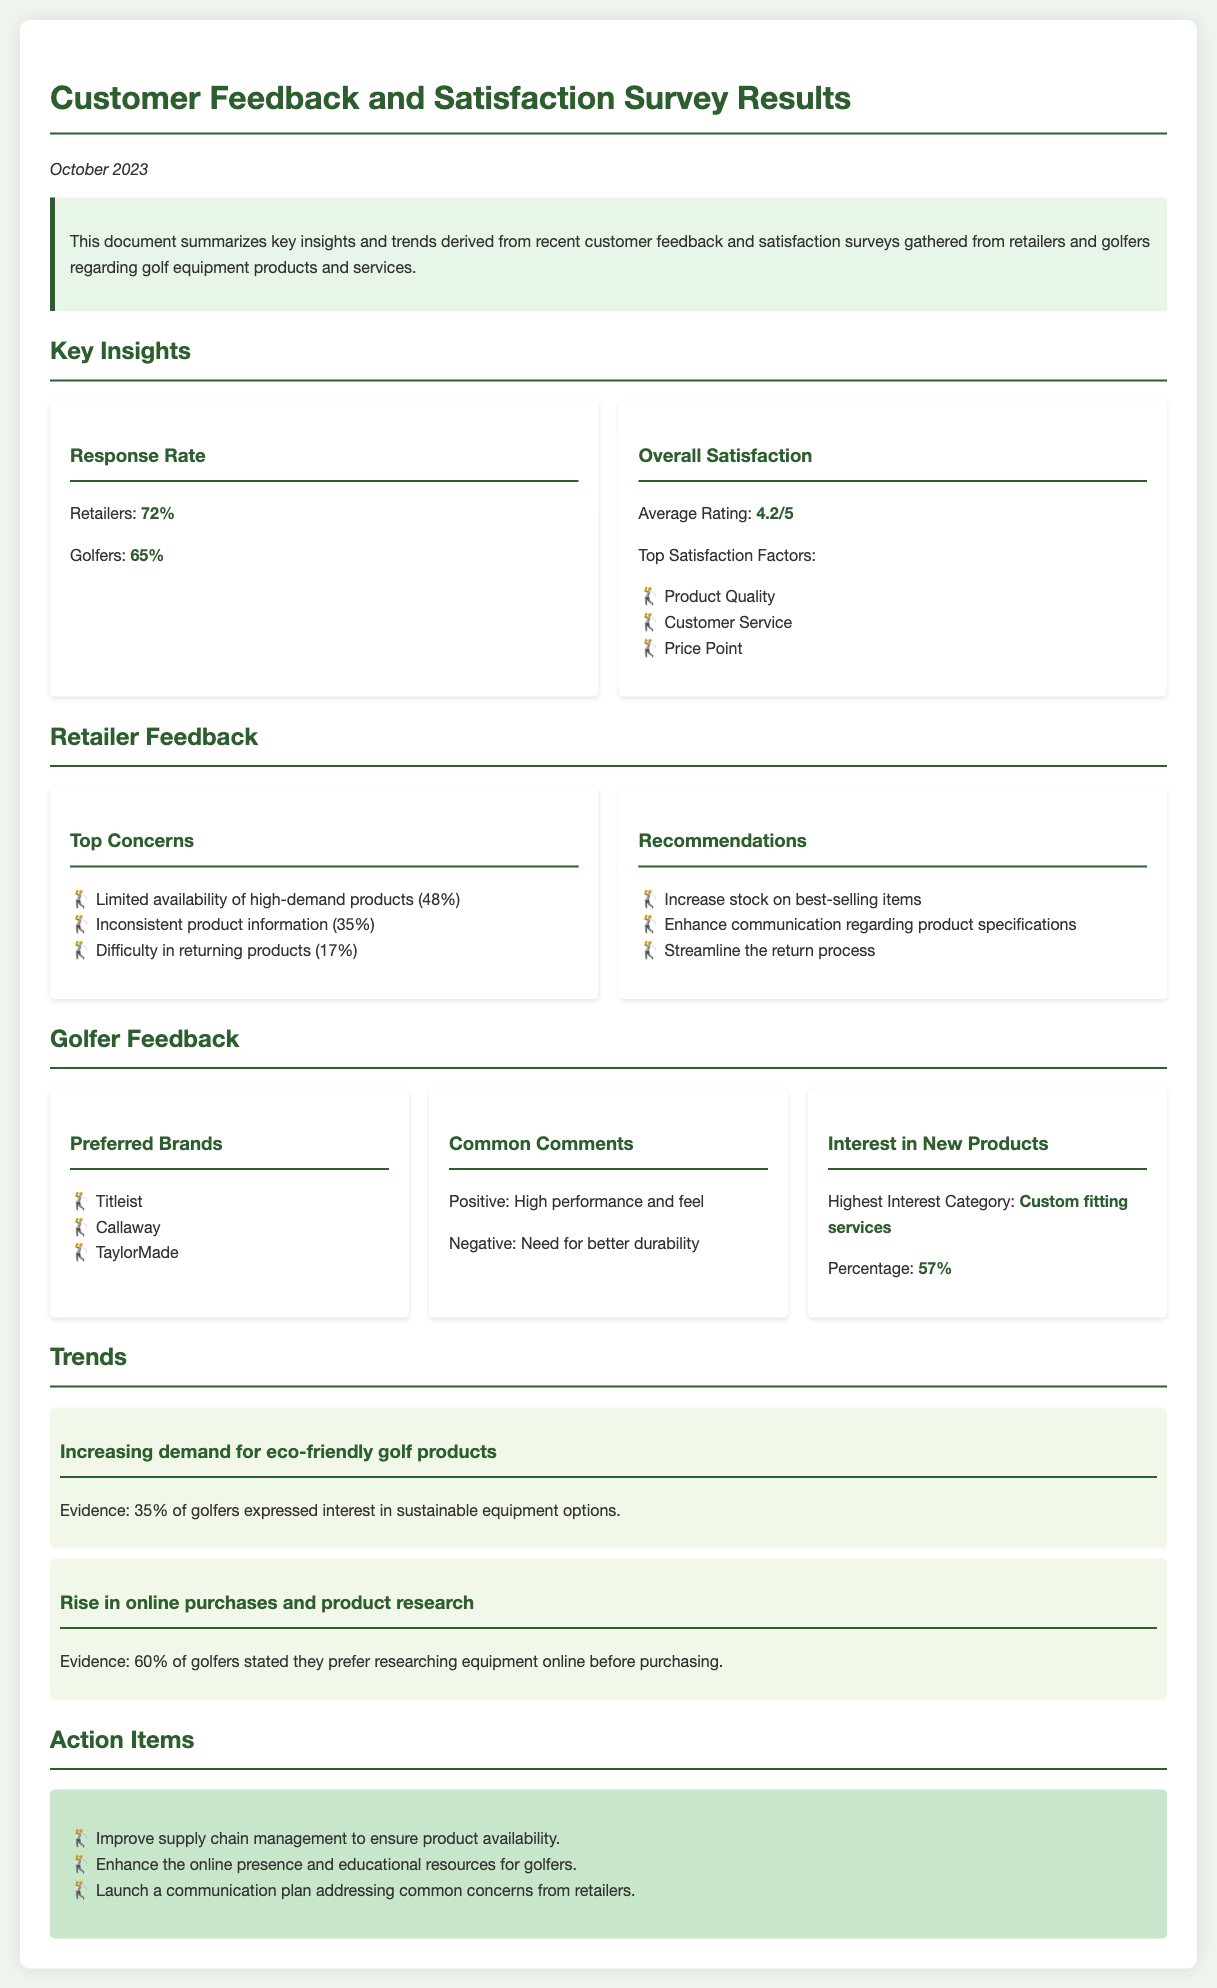What is the overall satisfaction average rating? The overall satisfaction average rating is stated in the document as the average of golfer feedback.
Answer: 4.2/5 What percentage of golfers stated a preference for researching equipment online? This percentage indicates a trend in golfer behavior concerning product research prior to purchase.
Answer: 60% What are the top satisfaction factors mentioned? The top satisfaction factors are categories that golfers highlighted in their feedback about the products and services received.
Answer: Product Quality, Customer Service, Price Point What is the highest interest category for new products among golfers? The document lists the interest expressed by golfers for new offerings related to equipment.
Answer: Custom fitting services What percentage of retailers expressed concerns over limited product availability? The document specifies a concern raised by retailers about stock issues affecting sales.
Answer: 48% What do golfers generally comment positively about? The document summarizes feedback from golfers, categorizing their sentiments into positive and negative observations.
Answer: High performance and feel What action item addresses retailer concerns? The action items are recommendations proposed to alleviate issues raised by retailers during the survey.
Answer: Launch a communication plan addressing common concerns from retailers What is the response rate from retailers? The response rate indicates the level of engagement from retailers in the satisfaction survey.
Answer: 72% What evidence supports increasing demand for eco-friendly products? This evidence derives from feedback regarding golfers' preferences for sustainable equipment options.
Answer: 35% 